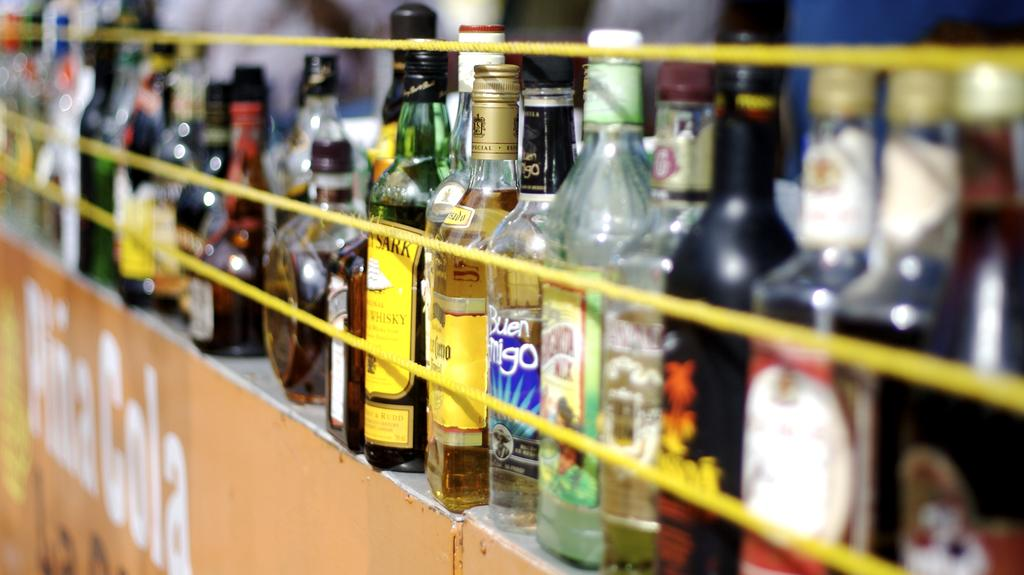What objects are present in the image? There are multiple bottles in the image, some of which are filled with liquid. Are there any additional elements in the image besides the bottles? Yes, there are ropes visible in the image. What is located at the bottom of the image? There is a banner at the bottom of the image. What book is the person reading on their throne in the image? There is no person, throne, or book present in the image; it only contains bottles, ropes, and a banner. 